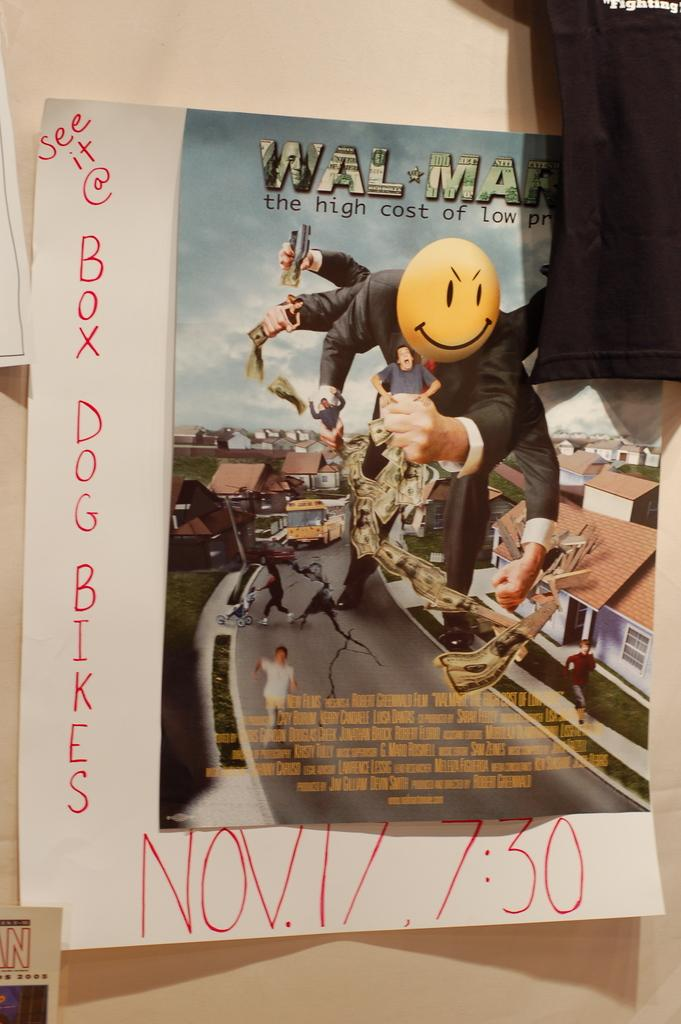What is on the wall in the image? There is a poster on the wall in the image. What type of glass can be seen on the back of the poster in the image? There is no glass visible on the poster or its back in the image. 